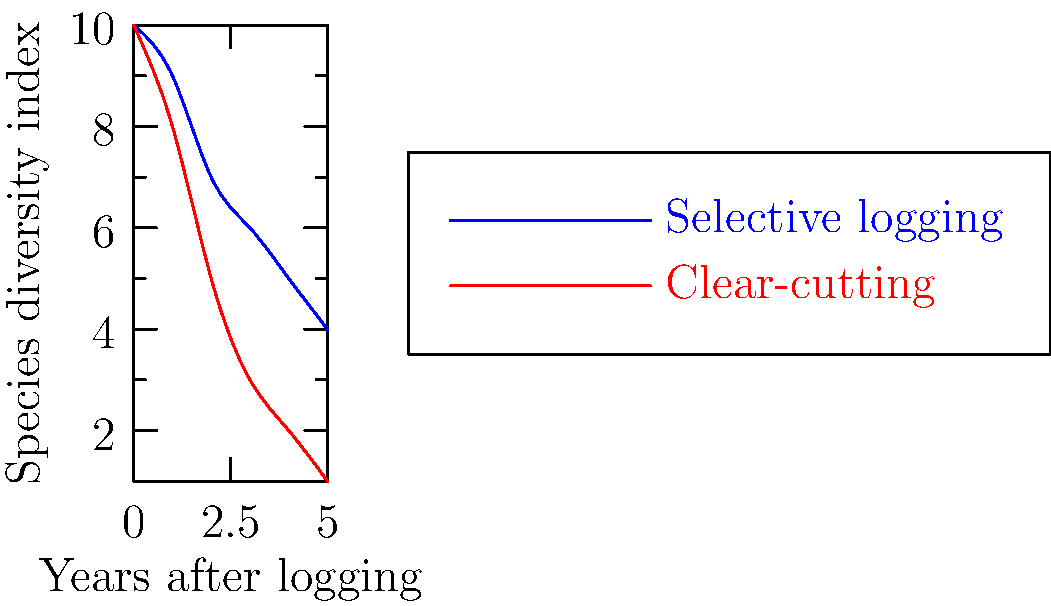Based on the species distribution graphs shown, which forest management practice appears to be more sustainable in terms of maintaining biodiversity over time? To answer this question, we need to analyze the two curves representing different logging practices:

1. Blue curve: Selective logging
2. Red curve: Clear-cutting

Let's examine the trends:

1. Initial impact (Year 0):
   - Both practices start at the same species diversity index (10).

2. Short-term impact (Years 1-2):
   - Selective logging: Gradual decrease to about 7.
   - Clear-cutting: Steep decrease to about 5.

3. Medium-term impact (Years 3-4):
   - Selective logging: Continued gradual decrease to about 5.
   - Clear-cutting: Continued steep decrease to about 2.

4. Long-term impact (Year 5):
   - Selective logging: Stabilizes around 4.
   - Clear-cutting: Continues to decrease, reaching about 1.

5. Overall trend:
   - Selective logging shows a more gradual decline and higher species diversity index throughout the period.
   - Clear-cutting shows a steeper decline and lower species diversity index.

6. Sustainability assessment:
   - Selective logging maintains a higher level of biodiversity over time.
   - Clear-cutting results in a more significant loss of biodiversity.

Therefore, based on the species distribution graphs, selective logging appears to be the more sustainable forest management practice in terms of maintaining biodiversity over time.
Answer: Selective logging 